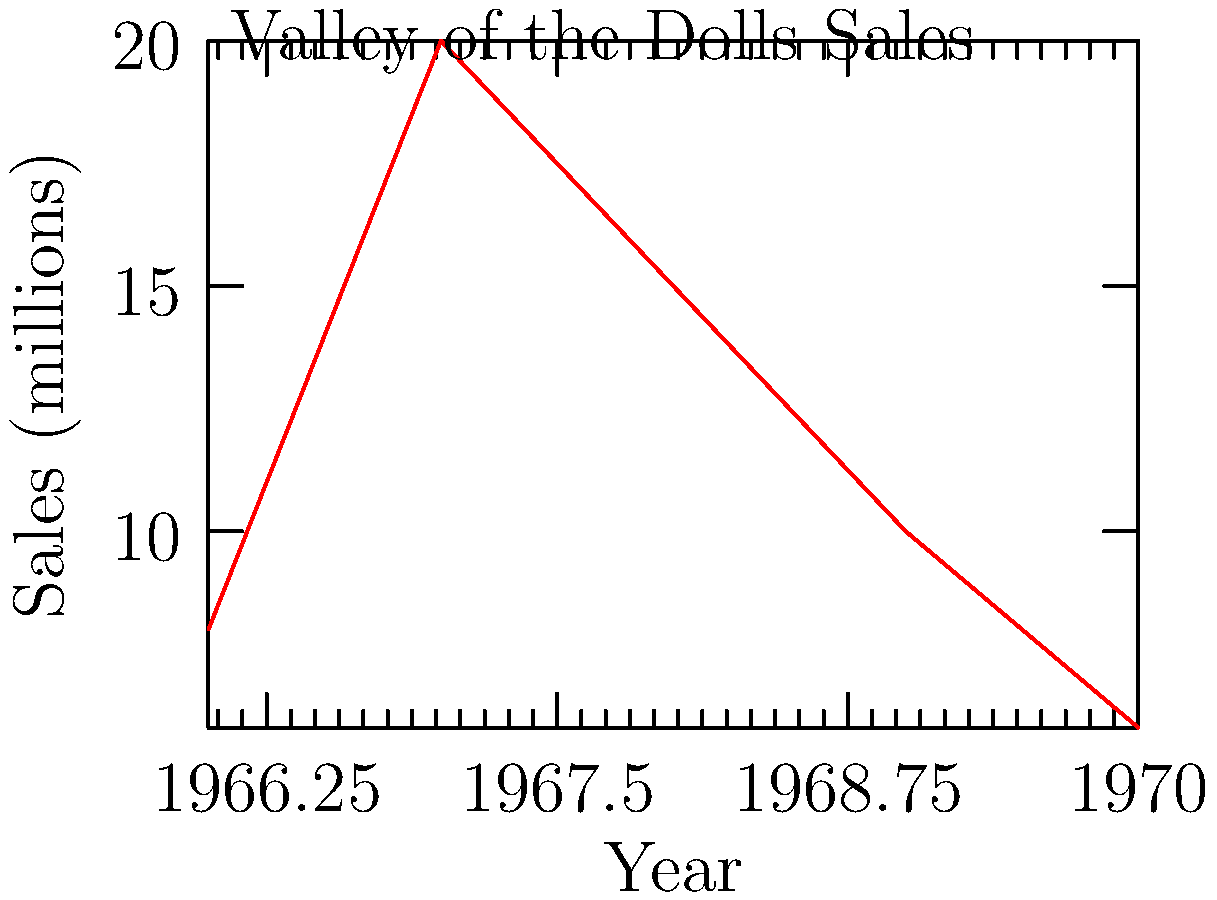Based on the line graph showing the sales figures of "Valley of the Dolls" over time, in which year did the book reach its peak sales? To determine the year of peak sales for "Valley of the Dolls," we need to follow these steps:

1. Observe the line graph, which shows sales figures from 1966 to 1970.
2. Identify the highest point on the graph, which represents the maximum sales.
3. The highest point on the graph corresponds to 20 million sales.
4. Locate the year that aligns with this peak on the x-axis.

Following these steps, we can see that the line reaches its highest point in 1967, indicating that this was the year of peak sales for "Valley of the Dolls."
Answer: 1967 